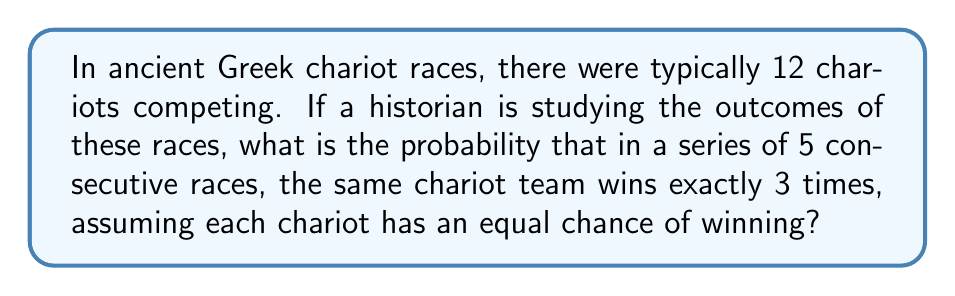Show me your answer to this math problem. To solve this problem, we need to use the concept of binomial probability. Let's break it down step-by-step:

1) First, we need to calculate the probability of a specific chariot winning a single race:
   $p = \frac{1}{12}$ (as there are 12 chariots with equal chances)

2) The probability of not winning is:
   $q = 1 - p = \frac{11}{12}$

3) We want the probability of winning exactly 3 out of 5 races. This follows a binomial distribution with parameters $n = 5$ (total number of races) and $k = 3$ (number of successes).

4) The binomial probability formula is:

   $$P(X = k) = \binom{n}{k} p^k (1-p)^{n-k}$$

   Where $\binom{n}{k}$ is the binomial coefficient, calculated as:

   $$\binom{n}{k} = \frac{n!}{k!(n-k)!}$$

5) Let's calculate the binomial coefficient:

   $$\binom{5}{3} = \frac{5!}{3!(5-3)!} = \frac{5 * 4 * 3!}{3! * 2!} = 10$$

6) Now, let's plug everything into the binomial probability formula:

   $$P(X = 3) = 10 * (\frac{1}{12})^3 * (\frac{11}{12})^2$$

7) Simplifying:

   $$P(X = 3) = 10 * \frac{1}{1728} * \frac{121}{144} = \frac{1210}{248832} \approx 0.004863$$

Therefore, the probability of a specific chariot winning exactly 3 out of 5 consecutive races is approximately 0.004863 or about 0.4863%.
Answer: $\frac{1210}{248832} \approx 0.004863$ or approximately 0.4863% 